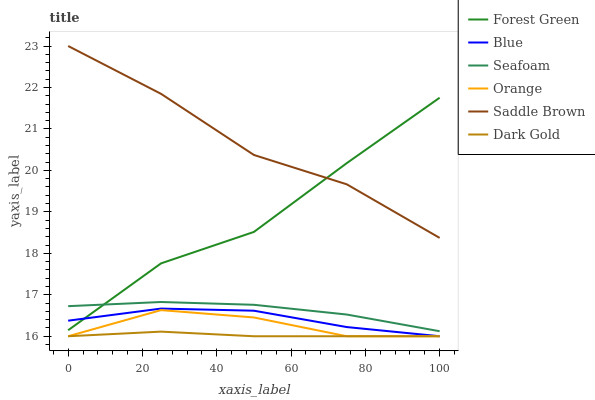Does Dark Gold have the minimum area under the curve?
Answer yes or no. Yes. Does Saddle Brown have the maximum area under the curve?
Answer yes or no. Yes. Does Seafoam have the minimum area under the curve?
Answer yes or no. No. Does Seafoam have the maximum area under the curve?
Answer yes or no. No. Is Dark Gold the smoothest?
Answer yes or no. Yes. Is Forest Green the roughest?
Answer yes or no. Yes. Is Seafoam the smoothest?
Answer yes or no. No. Is Seafoam the roughest?
Answer yes or no. No. Does Blue have the lowest value?
Answer yes or no. Yes. Does Seafoam have the lowest value?
Answer yes or no. No. Does Saddle Brown have the highest value?
Answer yes or no. Yes. Does Seafoam have the highest value?
Answer yes or no. No. Is Dark Gold less than Seafoam?
Answer yes or no. Yes. Is Seafoam greater than Blue?
Answer yes or no. Yes. Does Blue intersect Forest Green?
Answer yes or no. Yes. Is Blue less than Forest Green?
Answer yes or no. No. Is Blue greater than Forest Green?
Answer yes or no. No. Does Dark Gold intersect Seafoam?
Answer yes or no. No. 